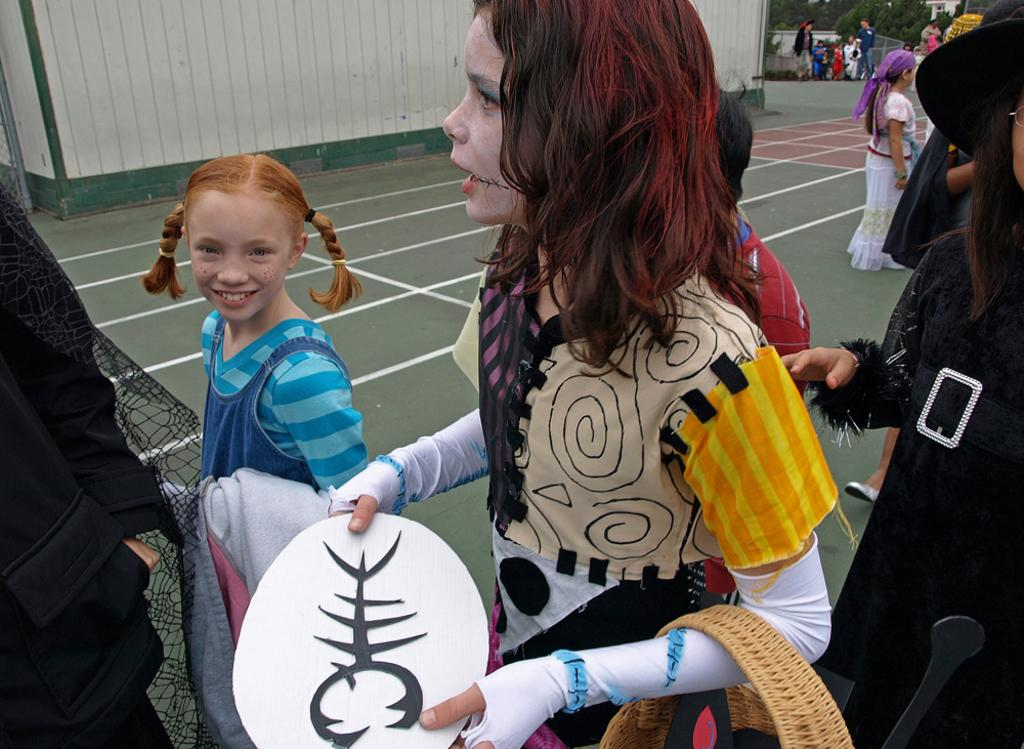What are the persons in the image wearing? The persons in the image are wearing fancy dress. What can be seen in the background of the image? There is a wall and trees in the background of the image. What type of appliance is visible in the image? There is no appliance present in the image. How many additional persons are present in the image, making a total of five? The number of persons in the image cannot be determined from the provided facts, so we cannot determine if there are five in total. 